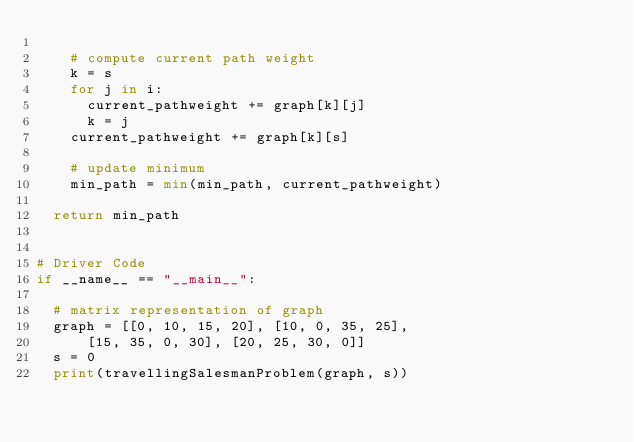<code> <loc_0><loc_0><loc_500><loc_500><_Python_>
		# compute current path weight 
		k = s 
		for j in i: 
			current_pathweight += graph[k][j] 
			k = j 
		current_pathweight += graph[k][s] 

		# update minimum 
		min_path = min(min_path, current_pathweight) 
		
	return min_path 


# Driver Code 
if __name__ == "__main__": 

	# matrix representation of graph 
	graph = [[0, 10, 15, 20], [10, 0, 35, 25], 
			[15, 35, 0, 30], [20, 25, 30, 0]] 
	s = 0
	print(travellingSalesmanProblem(graph, s))
</code> 